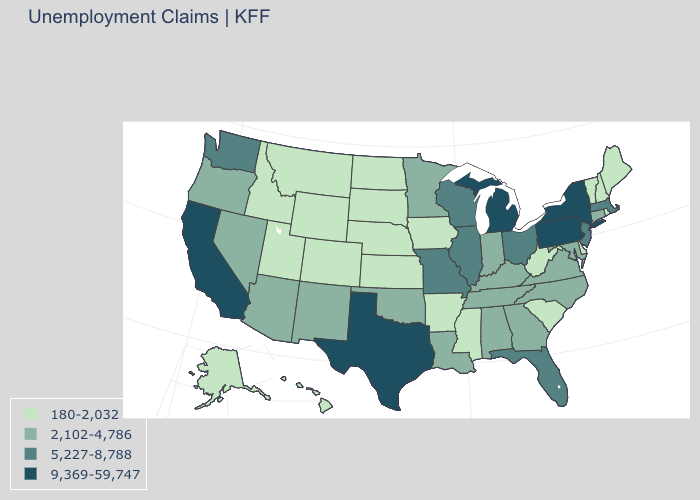What is the value of New Jersey?
Write a very short answer. 5,227-8,788. What is the value of Indiana?
Quick response, please. 2,102-4,786. What is the value of Mississippi?
Give a very brief answer. 180-2,032. How many symbols are there in the legend?
Short answer required. 4. What is the lowest value in states that border South Dakota?
Give a very brief answer. 180-2,032. Name the states that have a value in the range 180-2,032?
Concise answer only. Alaska, Arkansas, Colorado, Delaware, Hawaii, Idaho, Iowa, Kansas, Maine, Mississippi, Montana, Nebraska, New Hampshire, North Dakota, Rhode Island, South Carolina, South Dakota, Utah, Vermont, West Virginia, Wyoming. Name the states that have a value in the range 2,102-4,786?
Be succinct. Alabama, Arizona, Connecticut, Georgia, Indiana, Kentucky, Louisiana, Maryland, Minnesota, Nevada, New Mexico, North Carolina, Oklahoma, Oregon, Tennessee, Virginia. Name the states that have a value in the range 2,102-4,786?
Concise answer only. Alabama, Arizona, Connecticut, Georgia, Indiana, Kentucky, Louisiana, Maryland, Minnesota, Nevada, New Mexico, North Carolina, Oklahoma, Oregon, Tennessee, Virginia. Does Iowa have the highest value in the USA?
Concise answer only. No. Does Arkansas have a higher value than Montana?
Short answer required. No. Is the legend a continuous bar?
Give a very brief answer. No. Does Illinois have a higher value than North Carolina?
Short answer required. Yes. Does Louisiana have the same value as California?
Write a very short answer. No. 